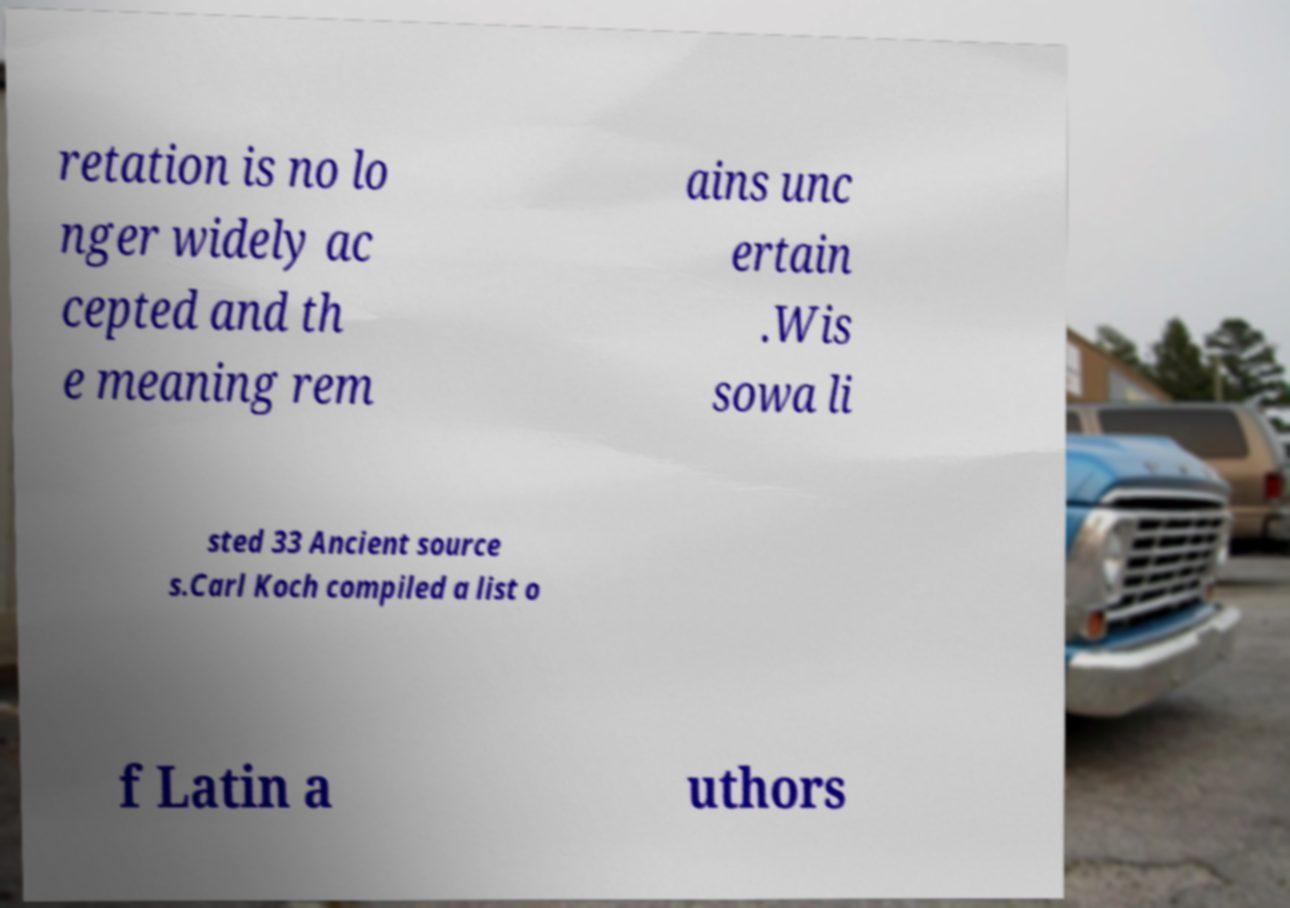Could you assist in decoding the text presented in this image and type it out clearly? retation is no lo nger widely ac cepted and th e meaning rem ains unc ertain .Wis sowa li sted 33 Ancient source s.Carl Koch compiled a list o f Latin a uthors 